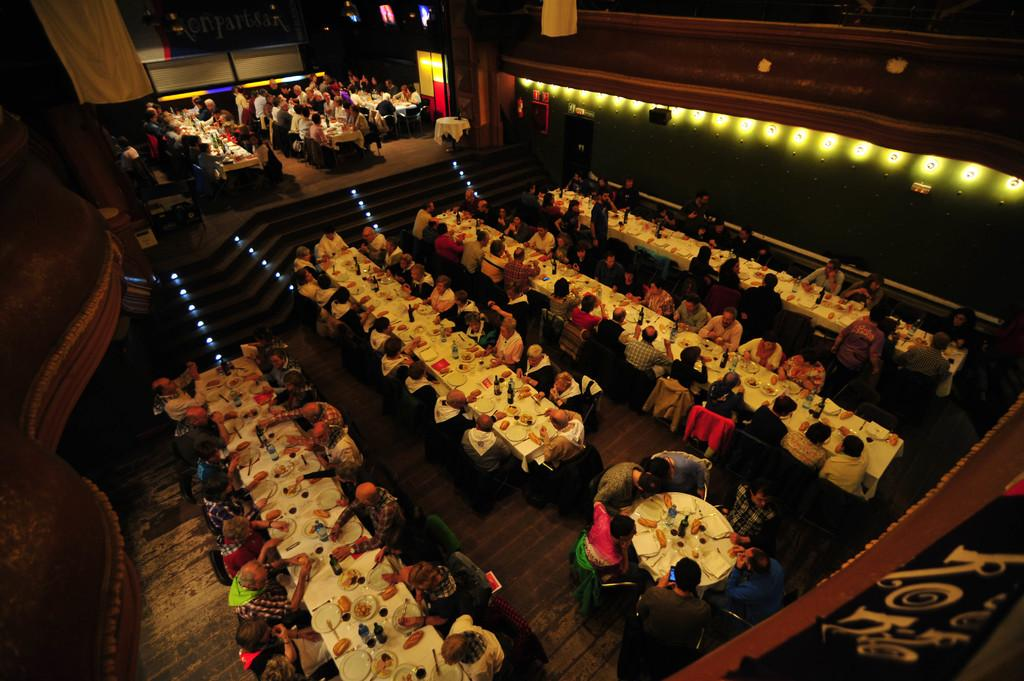What are the people in the image doing? The people in the image are sitting on chairs. What objects are present in the image besides the chairs? There are tables in the image. What can be found on the tables? There are food items on the tables. What can be seen illuminating the scene in the image? There are lights visible in the image. What is written or displayed at the top of the image? There is text at the top of the image. Can you describe the ghost that is present in the image? There is no ghost present in the image. What type of feeling can be seen on the faces of the people in the image? The image does not convey feelings or emotions on the faces of the people; it only shows their physical appearance. 